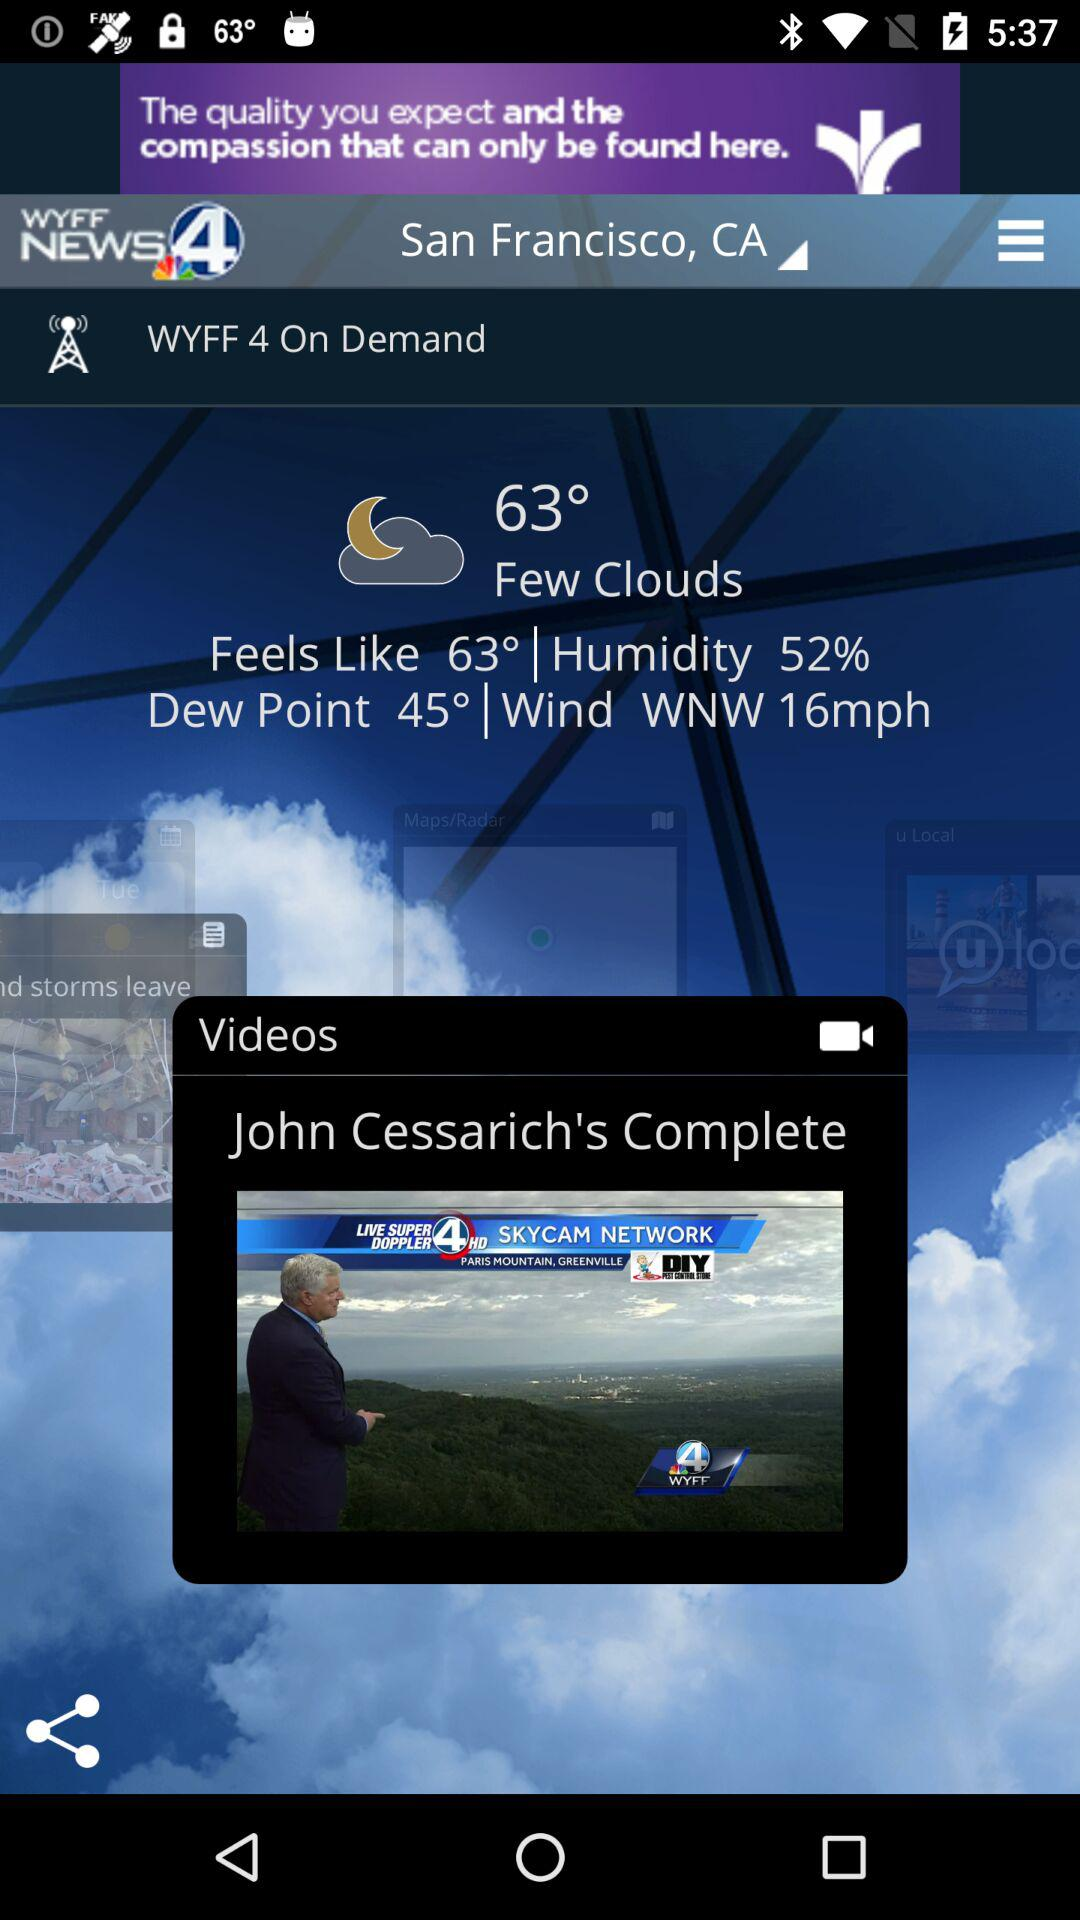How many more degrees is the temperature than the dew point?
Answer the question using a single word or phrase. 18 